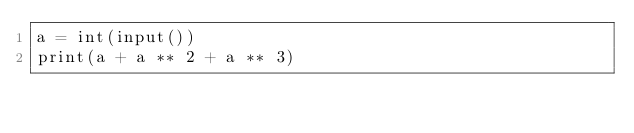<code> <loc_0><loc_0><loc_500><loc_500><_Python_>a = int(input())
print(a + a ** 2 + a ** 3)
</code> 